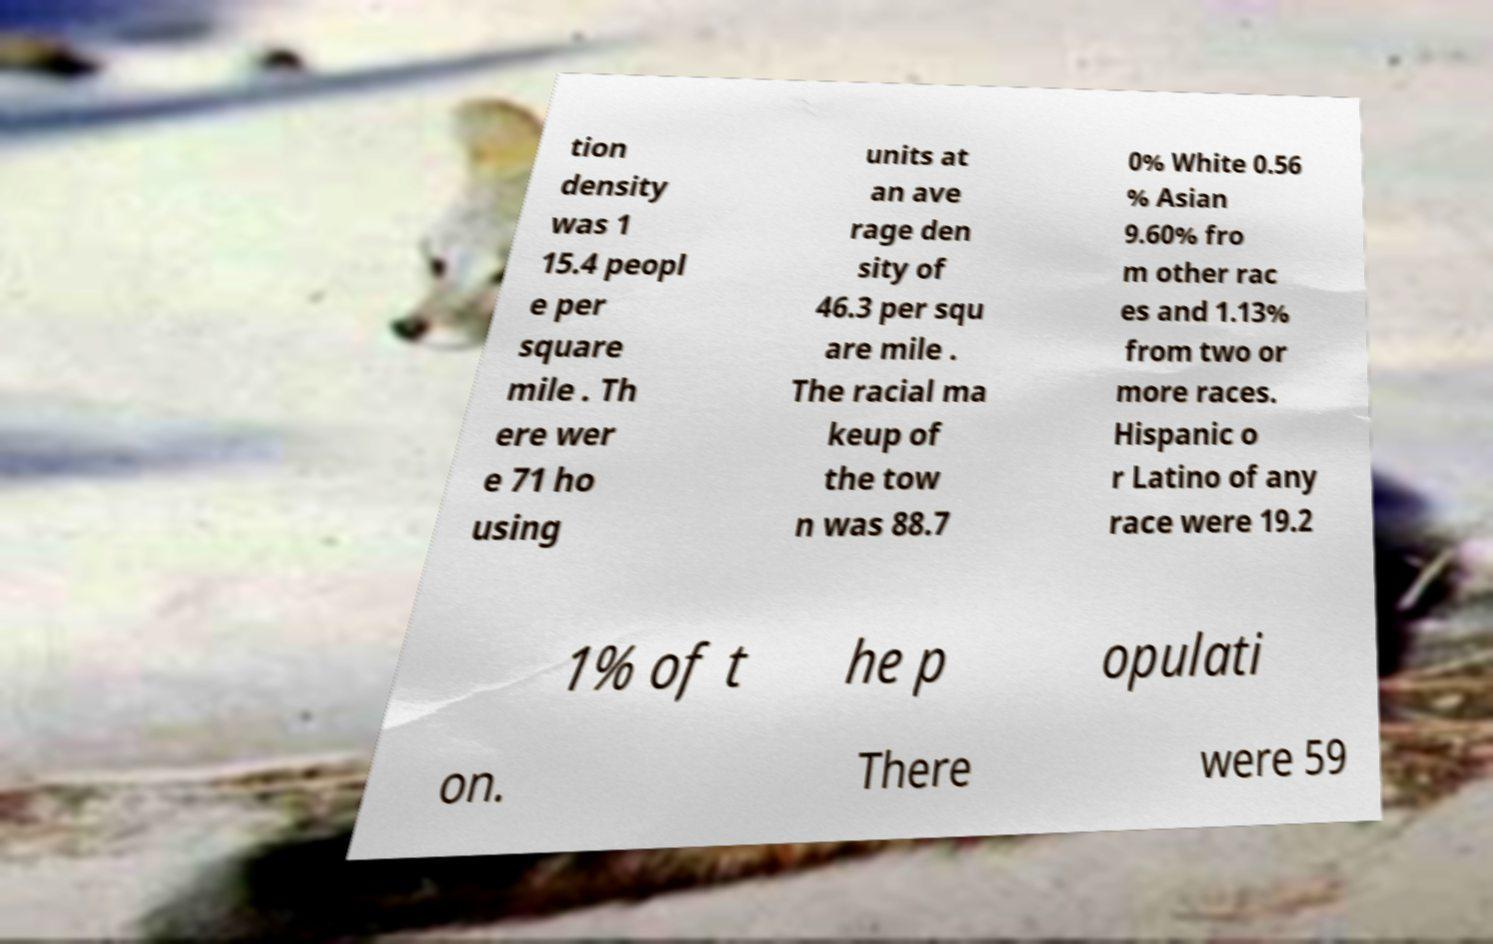There's text embedded in this image that I need extracted. Can you transcribe it verbatim? tion density was 1 15.4 peopl e per square mile . Th ere wer e 71 ho using units at an ave rage den sity of 46.3 per squ are mile . The racial ma keup of the tow n was 88.7 0% White 0.56 % Asian 9.60% fro m other rac es and 1.13% from two or more races. Hispanic o r Latino of any race were 19.2 1% of t he p opulati on. There were 59 